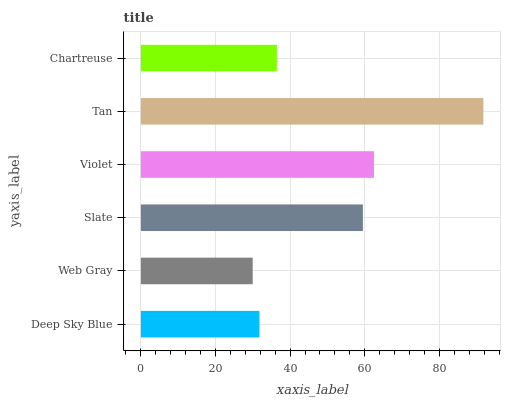Is Web Gray the minimum?
Answer yes or no. Yes. Is Tan the maximum?
Answer yes or no. Yes. Is Slate the minimum?
Answer yes or no. No. Is Slate the maximum?
Answer yes or no. No. Is Slate greater than Web Gray?
Answer yes or no. Yes. Is Web Gray less than Slate?
Answer yes or no. Yes. Is Web Gray greater than Slate?
Answer yes or no. No. Is Slate less than Web Gray?
Answer yes or no. No. Is Slate the high median?
Answer yes or no. Yes. Is Chartreuse the low median?
Answer yes or no. Yes. Is Violet the high median?
Answer yes or no. No. Is Deep Sky Blue the low median?
Answer yes or no. No. 